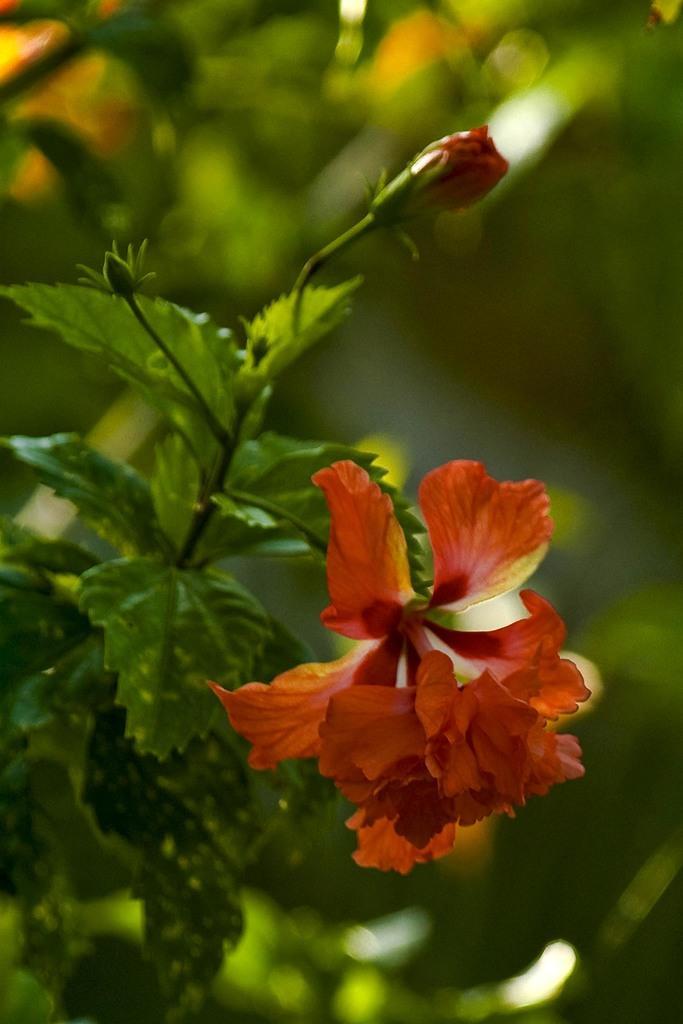Can you describe this image briefly? In the foreground of the picture there are flowers, bud and leaves. The background is blurred. In the background there is greenery. 